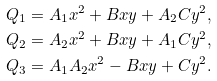Convert formula to latex. <formula><loc_0><loc_0><loc_500><loc_500>Q _ { 1 } & = A _ { 1 } x ^ { 2 } + B x y + A _ { 2 } C y ^ { 2 } , \\ Q _ { 2 } & = A _ { 2 } x ^ { 2 } + B x y + A _ { 1 } C y ^ { 2 } , \\ Q _ { 3 } & = A _ { 1 } A _ { 2 } x ^ { 2 } - B x y + C y ^ { 2 } .</formula> 